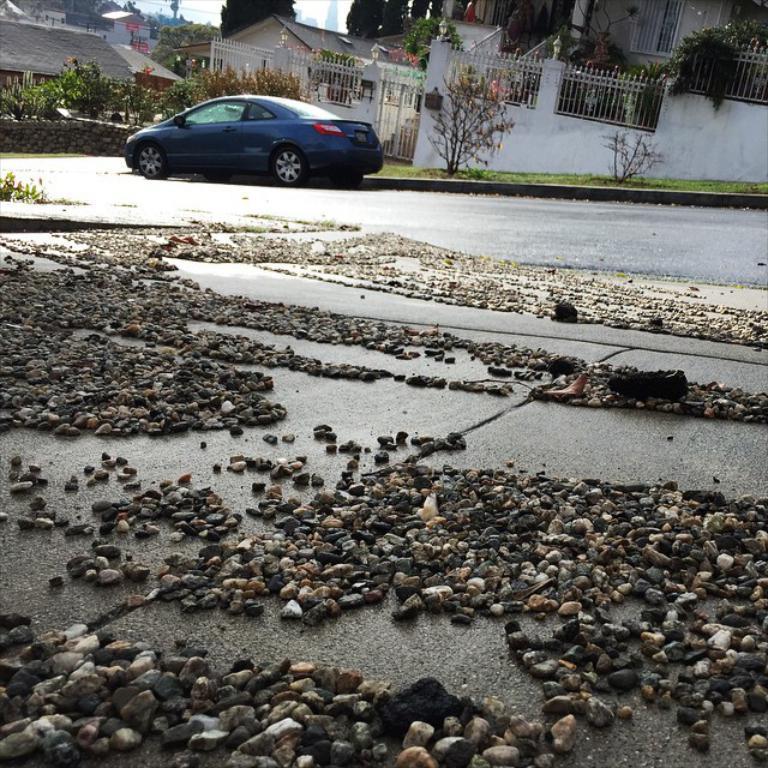How would you summarize this image in a sentence or two? In this image we can see stones, grass, plants, fence, wall, trees, houses, and sky. There is a car on the road. 